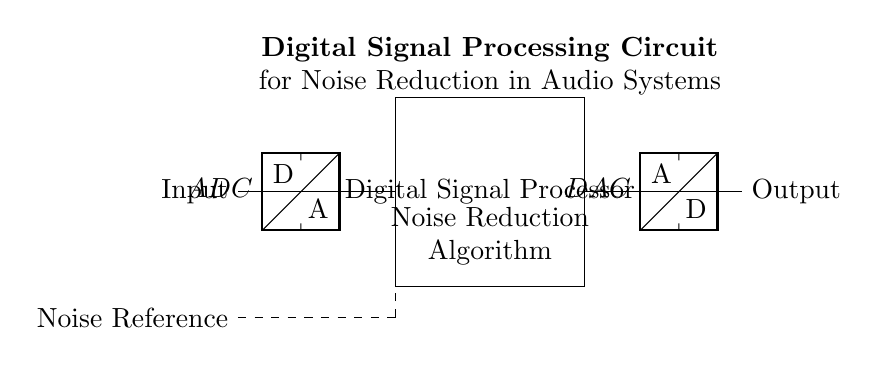What component converts the analog input signal? The ADC, or Analog to Digital Converter, is responsible for converting the analog input signal into a digital format that the digital signal processor can process.
Answer: ADC What is the primary function of the DSP block? The Digital Signal Processor block is designed to implement the noise reduction algorithm, which processes the incoming digital audio signal to reduce noise and enhance clarity.
Answer: Noise Reduction Algorithm What connects the ADC to the DSP block? The ADC output is connected to the DSP block via a direct electrical connection, allowing the digital signal to be processed immediately after conversion from the analog signal.
Answer: A wire How many components are involved in processing the signal? There are three main components involved in the processing of the signal: the ADC, the DSP block, and the DAC. Each component plays a critical role in the signal flow direction from input to output.
Answer: Three What type of signal is input into the circuit? The input signal is an analog signal that represents the original audio source before any processing takes place. This analog signal can have various forms of noise intermixed.
Answer: Analog What is represented by the dashed line in the circuit? The dashed line represents the noise reference, indicating the noise level that the DSP block is intended to reduce within the audio signal. This serves as a reference point for the noise reduction algorithm to compare against.
Answer: Noise Reference What type of output does the DAC produce? The DAC, or Digital to Analog Converter, transforms the processed digital signal back into an analog format suitable for playback through audio systems, ensuring that the human ear can perceive the sound.
Answer: Analog Output 